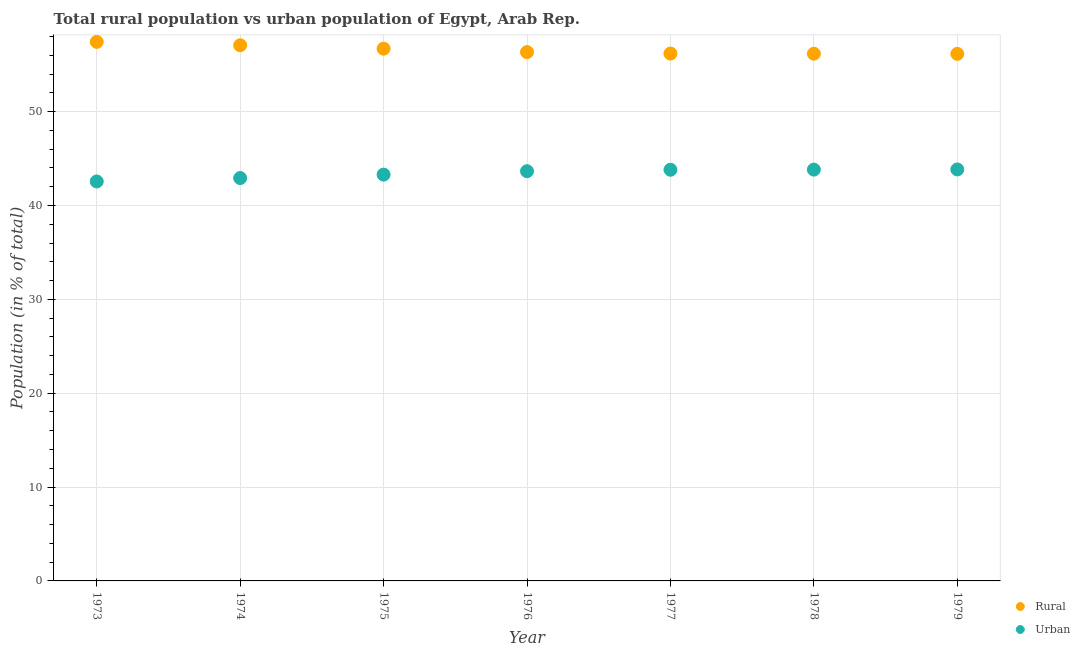How many different coloured dotlines are there?
Keep it short and to the point. 2. What is the rural population in 1973?
Make the answer very short. 57.44. Across all years, what is the maximum urban population?
Your response must be concise. 43.84. Across all years, what is the minimum urban population?
Ensure brevity in your answer.  42.56. In which year was the rural population maximum?
Your answer should be very brief. 1973. In which year was the rural population minimum?
Your response must be concise. 1979. What is the total rural population in the graph?
Keep it short and to the point. 396.09. What is the difference between the rural population in 1974 and that in 1979?
Give a very brief answer. 0.92. What is the difference between the urban population in 1977 and the rural population in 1973?
Keep it short and to the point. -13.63. What is the average urban population per year?
Ensure brevity in your answer.  43.42. In the year 1973, what is the difference between the rural population and urban population?
Your response must be concise. 14.87. What is the ratio of the rural population in 1974 to that in 1978?
Provide a short and direct response. 1.02. Is the rural population in 1976 less than that in 1979?
Provide a succinct answer. No. Is the difference between the urban population in 1973 and 1977 greater than the difference between the rural population in 1973 and 1977?
Your answer should be very brief. No. What is the difference between the highest and the second highest urban population?
Keep it short and to the point. 0.02. What is the difference between the highest and the lowest urban population?
Provide a short and direct response. 1.28. In how many years, is the rural population greater than the average rural population taken over all years?
Your response must be concise. 3. Is the sum of the rural population in 1976 and 1978 greater than the maximum urban population across all years?
Offer a terse response. Yes. Is the urban population strictly less than the rural population over the years?
Your answer should be very brief. Yes. How many years are there in the graph?
Offer a very short reply. 7. What is the difference between two consecutive major ticks on the Y-axis?
Your response must be concise. 10. Are the values on the major ticks of Y-axis written in scientific E-notation?
Offer a very short reply. No. Does the graph contain grids?
Make the answer very short. Yes. How many legend labels are there?
Your answer should be very brief. 2. What is the title of the graph?
Keep it short and to the point. Total rural population vs urban population of Egypt, Arab Rep. What is the label or title of the Y-axis?
Keep it short and to the point. Population (in % of total). What is the Population (in % of total) of Rural in 1973?
Keep it short and to the point. 57.44. What is the Population (in % of total) of Urban in 1973?
Provide a short and direct response. 42.56. What is the Population (in % of total) in Rural in 1974?
Provide a short and direct response. 57.07. What is the Population (in % of total) of Urban in 1974?
Your response must be concise. 42.93. What is the Population (in % of total) of Rural in 1975?
Ensure brevity in your answer.  56.71. What is the Population (in % of total) of Urban in 1975?
Provide a short and direct response. 43.29. What is the Population (in % of total) in Rural in 1976?
Offer a terse response. 56.34. What is the Population (in % of total) of Urban in 1976?
Make the answer very short. 43.66. What is the Population (in % of total) of Rural in 1977?
Your answer should be compact. 56.19. What is the Population (in % of total) of Urban in 1977?
Your answer should be very brief. 43.81. What is the Population (in % of total) of Rural in 1978?
Give a very brief answer. 56.17. What is the Population (in % of total) in Urban in 1978?
Provide a succinct answer. 43.83. What is the Population (in % of total) of Rural in 1979?
Give a very brief answer. 56.16. What is the Population (in % of total) in Urban in 1979?
Give a very brief answer. 43.84. Across all years, what is the maximum Population (in % of total) of Rural?
Your answer should be very brief. 57.44. Across all years, what is the maximum Population (in % of total) in Urban?
Make the answer very short. 43.84. Across all years, what is the minimum Population (in % of total) of Rural?
Make the answer very short. 56.16. Across all years, what is the minimum Population (in % of total) of Urban?
Your answer should be compact. 42.56. What is the total Population (in % of total) of Rural in the graph?
Give a very brief answer. 396.09. What is the total Population (in % of total) in Urban in the graph?
Give a very brief answer. 303.91. What is the difference between the Population (in % of total) in Rural in 1973 and that in 1974?
Your response must be concise. 0.36. What is the difference between the Population (in % of total) in Urban in 1973 and that in 1974?
Your response must be concise. -0.36. What is the difference between the Population (in % of total) in Rural in 1973 and that in 1975?
Provide a succinct answer. 0.73. What is the difference between the Population (in % of total) of Urban in 1973 and that in 1975?
Your response must be concise. -0.73. What is the difference between the Population (in % of total) of Rural in 1973 and that in 1976?
Your answer should be very brief. 1.09. What is the difference between the Population (in % of total) in Urban in 1973 and that in 1976?
Give a very brief answer. -1.09. What is the difference between the Population (in % of total) in Rural in 1973 and that in 1977?
Keep it short and to the point. 1.25. What is the difference between the Population (in % of total) of Urban in 1973 and that in 1977?
Offer a terse response. -1.25. What is the difference between the Population (in % of total) of Rural in 1973 and that in 1978?
Keep it short and to the point. 1.26. What is the difference between the Population (in % of total) of Urban in 1973 and that in 1978?
Offer a very short reply. -1.26. What is the difference between the Population (in % of total) in Rural in 1973 and that in 1979?
Offer a terse response. 1.28. What is the difference between the Population (in % of total) of Urban in 1973 and that in 1979?
Keep it short and to the point. -1.28. What is the difference between the Population (in % of total) in Rural in 1974 and that in 1975?
Make the answer very short. 0.36. What is the difference between the Population (in % of total) of Urban in 1974 and that in 1975?
Provide a short and direct response. -0.36. What is the difference between the Population (in % of total) of Rural in 1974 and that in 1976?
Offer a terse response. 0.73. What is the difference between the Population (in % of total) of Urban in 1974 and that in 1976?
Offer a very short reply. -0.73. What is the difference between the Population (in % of total) in Rural in 1974 and that in 1977?
Offer a terse response. 0.88. What is the difference between the Population (in % of total) in Urban in 1974 and that in 1977?
Your response must be concise. -0.88. What is the difference between the Population (in % of total) in Rural in 1974 and that in 1979?
Your response must be concise. 0.92. What is the difference between the Population (in % of total) of Urban in 1974 and that in 1979?
Your response must be concise. -0.92. What is the difference between the Population (in % of total) in Rural in 1975 and that in 1976?
Provide a succinct answer. 0.36. What is the difference between the Population (in % of total) in Urban in 1975 and that in 1976?
Provide a succinct answer. -0.36. What is the difference between the Population (in % of total) of Rural in 1975 and that in 1977?
Ensure brevity in your answer.  0.52. What is the difference between the Population (in % of total) of Urban in 1975 and that in 1977?
Make the answer very short. -0.52. What is the difference between the Population (in % of total) of Rural in 1975 and that in 1978?
Offer a very short reply. 0.54. What is the difference between the Population (in % of total) of Urban in 1975 and that in 1978?
Ensure brevity in your answer.  -0.54. What is the difference between the Population (in % of total) in Rural in 1975 and that in 1979?
Give a very brief answer. 0.55. What is the difference between the Population (in % of total) of Urban in 1975 and that in 1979?
Your answer should be very brief. -0.55. What is the difference between the Population (in % of total) in Rural in 1976 and that in 1977?
Provide a succinct answer. 0.15. What is the difference between the Population (in % of total) of Urban in 1976 and that in 1977?
Give a very brief answer. -0.15. What is the difference between the Population (in % of total) in Rural in 1976 and that in 1978?
Your answer should be very brief. 0.17. What is the difference between the Population (in % of total) in Urban in 1976 and that in 1978?
Offer a very short reply. -0.17. What is the difference between the Population (in % of total) of Rural in 1976 and that in 1979?
Offer a very short reply. 0.19. What is the difference between the Population (in % of total) in Urban in 1976 and that in 1979?
Your response must be concise. -0.19. What is the difference between the Population (in % of total) in Rural in 1977 and that in 1978?
Provide a short and direct response. 0.02. What is the difference between the Population (in % of total) of Urban in 1977 and that in 1978?
Provide a short and direct response. -0.02. What is the difference between the Population (in % of total) of Rural in 1977 and that in 1979?
Keep it short and to the point. 0.03. What is the difference between the Population (in % of total) in Urban in 1977 and that in 1979?
Offer a terse response. -0.03. What is the difference between the Population (in % of total) of Rural in 1978 and that in 1979?
Offer a terse response. 0.02. What is the difference between the Population (in % of total) of Urban in 1978 and that in 1979?
Provide a succinct answer. -0.02. What is the difference between the Population (in % of total) in Rural in 1973 and the Population (in % of total) in Urban in 1974?
Provide a short and direct response. 14.51. What is the difference between the Population (in % of total) in Rural in 1973 and the Population (in % of total) in Urban in 1975?
Give a very brief answer. 14.15. What is the difference between the Population (in % of total) in Rural in 1973 and the Population (in % of total) in Urban in 1976?
Your answer should be very brief. 13.78. What is the difference between the Population (in % of total) in Rural in 1973 and the Population (in % of total) in Urban in 1977?
Your answer should be compact. 13.63. What is the difference between the Population (in % of total) in Rural in 1973 and the Population (in % of total) in Urban in 1978?
Ensure brevity in your answer.  13.61. What is the difference between the Population (in % of total) in Rural in 1973 and the Population (in % of total) in Urban in 1979?
Your answer should be compact. 13.6. What is the difference between the Population (in % of total) in Rural in 1974 and the Population (in % of total) in Urban in 1975?
Provide a succinct answer. 13.78. What is the difference between the Population (in % of total) of Rural in 1974 and the Population (in % of total) of Urban in 1976?
Provide a short and direct response. 13.42. What is the difference between the Population (in % of total) of Rural in 1974 and the Population (in % of total) of Urban in 1977?
Offer a terse response. 13.26. What is the difference between the Population (in % of total) in Rural in 1974 and the Population (in % of total) in Urban in 1978?
Provide a succinct answer. 13.25. What is the difference between the Population (in % of total) of Rural in 1974 and the Population (in % of total) of Urban in 1979?
Provide a short and direct response. 13.23. What is the difference between the Population (in % of total) of Rural in 1975 and the Population (in % of total) of Urban in 1976?
Your response must be concise. 13.05. What is the difference between the Population (in % of total) in Rural in 1975 and the Population (in % of total) in Urban in 1977?
Your answer should be compact. 12.9. What is the difference between the Population (in % of total) in Rural in 1975 and the Population (in % of total) in Urban in 1978?
Your response must be concise. 12.88. What is the difference between the Population (in % of total) in Rural in 1975 and the Population (in % of total) in Urban in 1979?
Keep it short and to the point. 12.87. What is the difference between the Population (in % of total) in Rural in 1976 and the Population (in % of total) in Urban in 1977?
Keep it short and to the point. 12.53. What is the difference between the Population (in % of total) in Rural in 1976 and the Population (in % of total) in Urban in 1978?
Your response must be concise. 12.52. What is the difference between the Population (in % of total) in Rural in 1976 and the Population (in % of total) in Urban in 1979?
Ensure brevity in your answer.  12.5. What is the difference between the Population (in % of total) of Rural in 1977 and the Population (in % of total) of Urban in 1978?
Provide a short and direct response. 12.36. What is the difference between the Population (in % of total) of Rural in 1977 and the Population (in % of total) of Urban in 1979?
Make the answer very short. 12.35. What is the difference between the Population (in % of total) in Rural in 1978 and the Population (in % of total) in Urban in 1979?
Your answer should be compact. 12.33. What is the average Population (in % of total) in Rural per year?
Give a very brief answer. 56.58. What is the average Population (in % of total) in Urban per year?
Your answer should be very brief. 43.42. In the year 1973, what is the difference between the Population (in % of total) of Rural and Population (in % of total) of Urban?
Keep it short and to the point. 14.87. In the year 1974, what is the difference between the Population (in % of total) of Rural and Population (in % of total) of Urban?
Your response must be concise. 14.15. In the year 1975, what is the difference between the Population (in % of total) in Rural and Population (in % of total) in Urban?
Your answer should be compact. 13.42. In the year 1976, what is the difference between the Population (in % of total) of Rural and Population (in % of total) of Urban?
Keep it short and to the point. 12.69. In the year 1977, what is the difference between the Population (in % of total) in Rural and Population (in % of total) in Urban?
Provide a succinct answer. 12.38. In the year 1978, what is the difference between the Population (in % of total) in Rural and Population (in % of total) in Urban?
Provide a succinct answer. 12.35. In the year 1979, what is the difference between the Population (in % of total) in Rural and Population (in % of total) in Urban?
Your answer should be compact. 12.32. What is the ratio of the Population (in % of total) in Rural in 1973 to that in 1974?
Offer a terse response. 1.01. What is the ratio of the Population (in % of total) in Rural in 1973 to that in 1975?
Your response must be concise. 1.01. What is the ratio of the Population (in % of total) of Urban in 1973 to that in 1975?
Offer a very short reply. 0.98. What is the ratio of the Population (in % of total) in Rural in 1973 to that in 1976?
Provide a succinct answer. 1.02. What is the ratio of the Population (in % of total) of Rural in 1973 to that in 1977?
Your answer should be very brief. 1.02. What is the ratio of the Population (in % of total) in Urban in 1973 to that in 1977?
Make the answer very short. 0.97. What is the ratio of the Population (in % of total) of Rural in 1973 to that in 1978?
Offer a very short reply. 1.02. What is the ratio of the Population (in % of total) in Urban in 1973 to that in 1978?
Your answer should be very brief. 0.97. What is the ratio of the Population (in % of total) in Rural in 1973 to that in 1979?
Your answer should be compact. 1.02. What is the ratio of the Population (in % of total) of Urban in 1973 to that in 1979?
Offer a terse response. 0.97. What is the ratio of the Population (in % of total) of Rural in 1974 to that in 1975?
Provide a short and direct response. 1.01. What is the ratio of the Population (in % of total) in Rural in 1974 to that in 1976?
Offer a terse response. 1.01. What is the ratio of the Population (in % of total) of Urban in 1974 to that in 1976?
Ensure brevity in your answer.  0.98. What is the ratio of the Population (in % of total) of Rural in 1974 to that in 1977?
Provide a short and direct response. 1.02. What is the ratio of the Population (in % of total) of Urban in 1974 to that in 1977?
Provide a short and direct response. 0.98. What is the ratio of the Population (in % of total) of Urban in 1974 to that in 1978?
Keep it short and to the point. 0.98. What is the ratio of the Population (in % of total) of Rural in 1974 to that in 1979?
Ensure brevity in your answer.  1.02. What is the ratio of the Population (in % of total) of Urban in 1974 to that in 1979?
Make the answer very short. 0.98. What is the ratio of the Population (in % of total) of Rural in 1975 to that in 1977?
Keep it short and to the point. 1.01. What is the ratio of the Population (in % of total) of Rural in 1975 to that in 1978?
Provide a succinct answer. 1.01. What is the ratio of the Population (in % of total) of Rural in 1975 to that in 1979?
Give a very brief answer. 1.01. What is the ratio of the Population (in % of total) of Urban in 1975 to that in 1979?
Your answer should be compact. 0.99. What is the ratio of the Population (in % of total) in Rural in 1976 to that in 1977?
Your answer should be very brief. 1. What is the ratio of the Population (in % of total) in Rural in 1976 to that in 1978?
Provide a succinct answer. 1. What is the ratio of the Population (in % of total) in Urban in 1976 to that in 1978?
Keep it short and to the point. 1. What is the ratio of the Population (in % of total) in Rural in 1976 to that in 1979?
Offer a very short reply. 1. What is the ratio of the Population (in % of total) of Rural in 1977 to that in 1978?
Your answer should be very brief. 1. What is the ratio of the Population (in % of total) in Urban in 1977 to that in 1978?
Make the answer very short. 1. What is the difference between the highest and the second highest Population (in % of total) of Rural?
Provide a succinct answer. 0.36. What is the difference between the highest and the second highest Population (in % of total) in Urban?
Give a very brief answer. 0.02. What is the difference between the highest and the lowest Population (in % of total) in Rural?
Offer a very short reply. 1.28. What is the difference between the highest and the lowest Population (in % of total) of Urban?
Your answer should be compact. 1.28. 